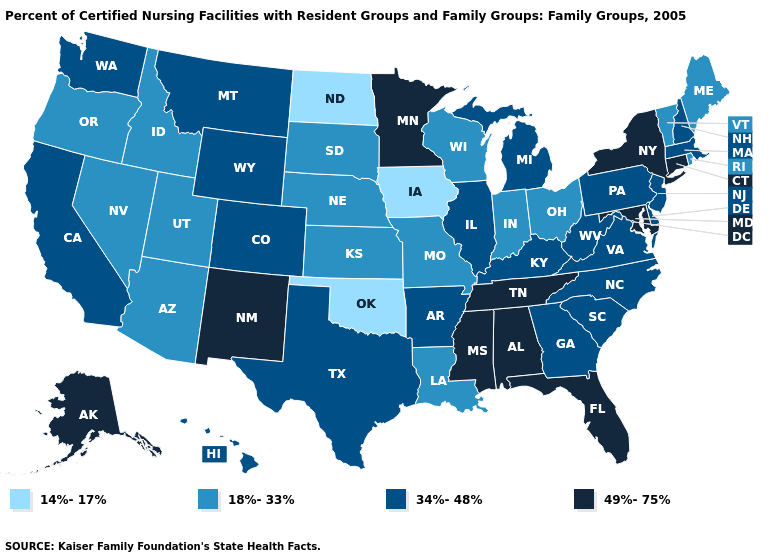Name the states that have a value in the range 34%-48%?
Short answer required. Arkansas, California, Colorado, Delaware, Georgia, Hawaii, Illinois, Kentucky, Massachusetts, Michigan, Montana, New Hampshire, New Jersey, North Carolina, Pennsylvania, South Carolina, Texas, Virginia, Washington, West Virginia, Wyoming. Among the states that border Virginia , does West Virginia have the lowest value?
Answer briefly. Yes. Name the states that have a value in the range 49%-75%?
Give a very brief answer. Alabama, Alaska, Connecticut, Florida, Maryland, Minnesota, Mississippi, New Mexico, New York, Tennessee. What is the value of Nebraska?
Short answer required. 18%-33%. Name the states that have a value in the range 49%-75%?
Be succinct. Alabama, Alaska, Connecticut, Florida, Maryland, Minnesota, Mississippi, New Mexico, New York, Tennessee. Does Iowa have the lowest value in the MidWest?
Keep it brief. Yes. Name the states that have a value in the range 49%-75%?
Be succinct. Alabama, Alaska, Connecticut, Florida, Maryland, Minnesota, Mississippi, New Mexico, New York, Tennessee. Does the map have missing data?
Be succinct. No. Does the map have missing data?
Be succinct. No. Name the states that have a value in the range 49%-75%?
Give a very brief answer. Alabama, Alaska, Connecticut, Florida, Maryland, Minnesota, Mississippi, New Mexico, New York, Tennessee. What is the value of Oregon?
Be succinct. 18%-33%. Name the states that have a value in the range 34%-48%?
Quick response, please. Arkansas, California, Colorado, Delaware, Georgia, Hawaii, Illinois, Kentucky, Massachusetts, Michigan, Montana, New Hampshire, New Jersey, North Carolina, Pennsylvania, South Carolina, Texas, Virginia, Washington, West Virginia, Wyoming. Name the states that have a value in the range 18%-33%?
Give a very brief answer. Arizona, Idaho, Indiana, Kansas, Louisiana, Maine, Missouri, Nebraska, Nevada, Ohio, Oregon, Rhode Island, South Dakota, Utah, Vermont, Wisconsin. Name the states that have a value in the range 34%-48%?
Keep it brief. Arkansas, California, Colorado, Delaware, Georgia, Hawaii, Illinois, Kentucky, Massachusetts, Michigan, Montana, New Hampshire, New Jersey, North Carolina, Pennsylvania, South Carolina, Texas, Virginia, Washington, West Virginia, Wyoming. Does Minnesota have a lower value than Indiana?
Give a very brief answer. No. 